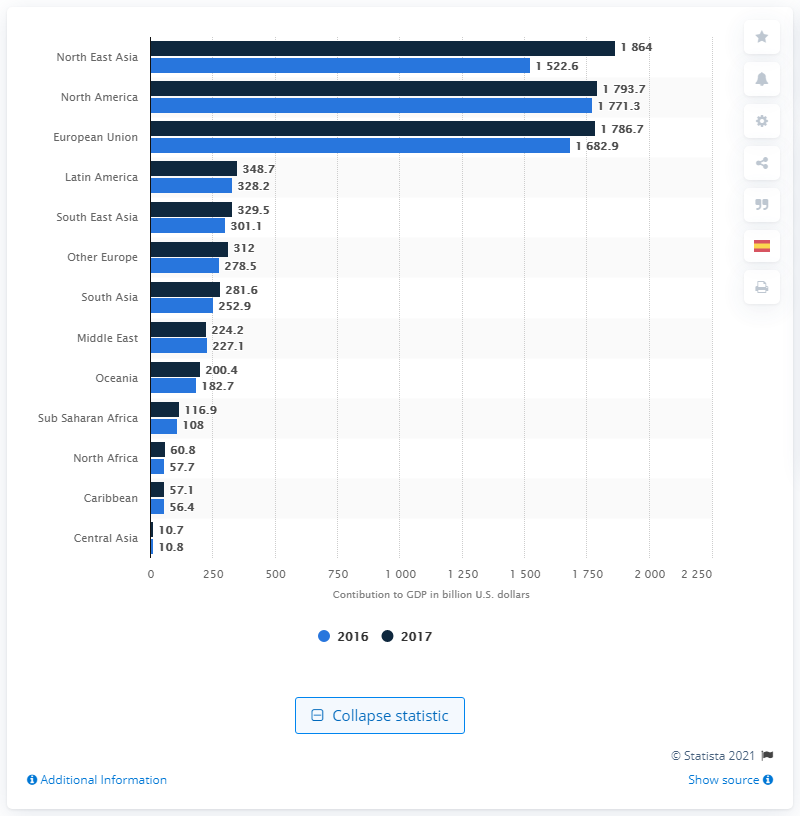Draw attention to some important aspects in this diagram. In 2017, the travel and tourism sector contributed a total of $179.37 billion to the economy of North East Asia. 